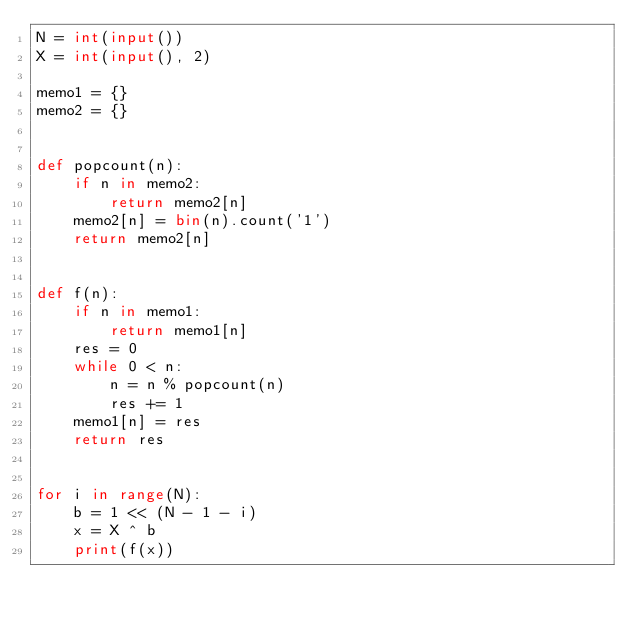Convert code to text. <code><loc_0><loc_0><loc_500><loc_500><_Python_>N = int(input())
X = int(input(), 2)

memo1 = {}
memo2 = {}


def popcount(n):
    if n in memo2:
        return memo2[n]
    memo2[n] = bin(n).count('1')
    return memo2[n]


def f(n):
    if n in memo1:
        return memo1[n]
    res = 0
    while 0 < n:
        n = n % popcount(n)
        res += 1
    memo1[n] = res
    return res


for i in range(N):
    b = 1 << (N - 1 - i)
    x = X ^ b
    print(f(x))</code> 